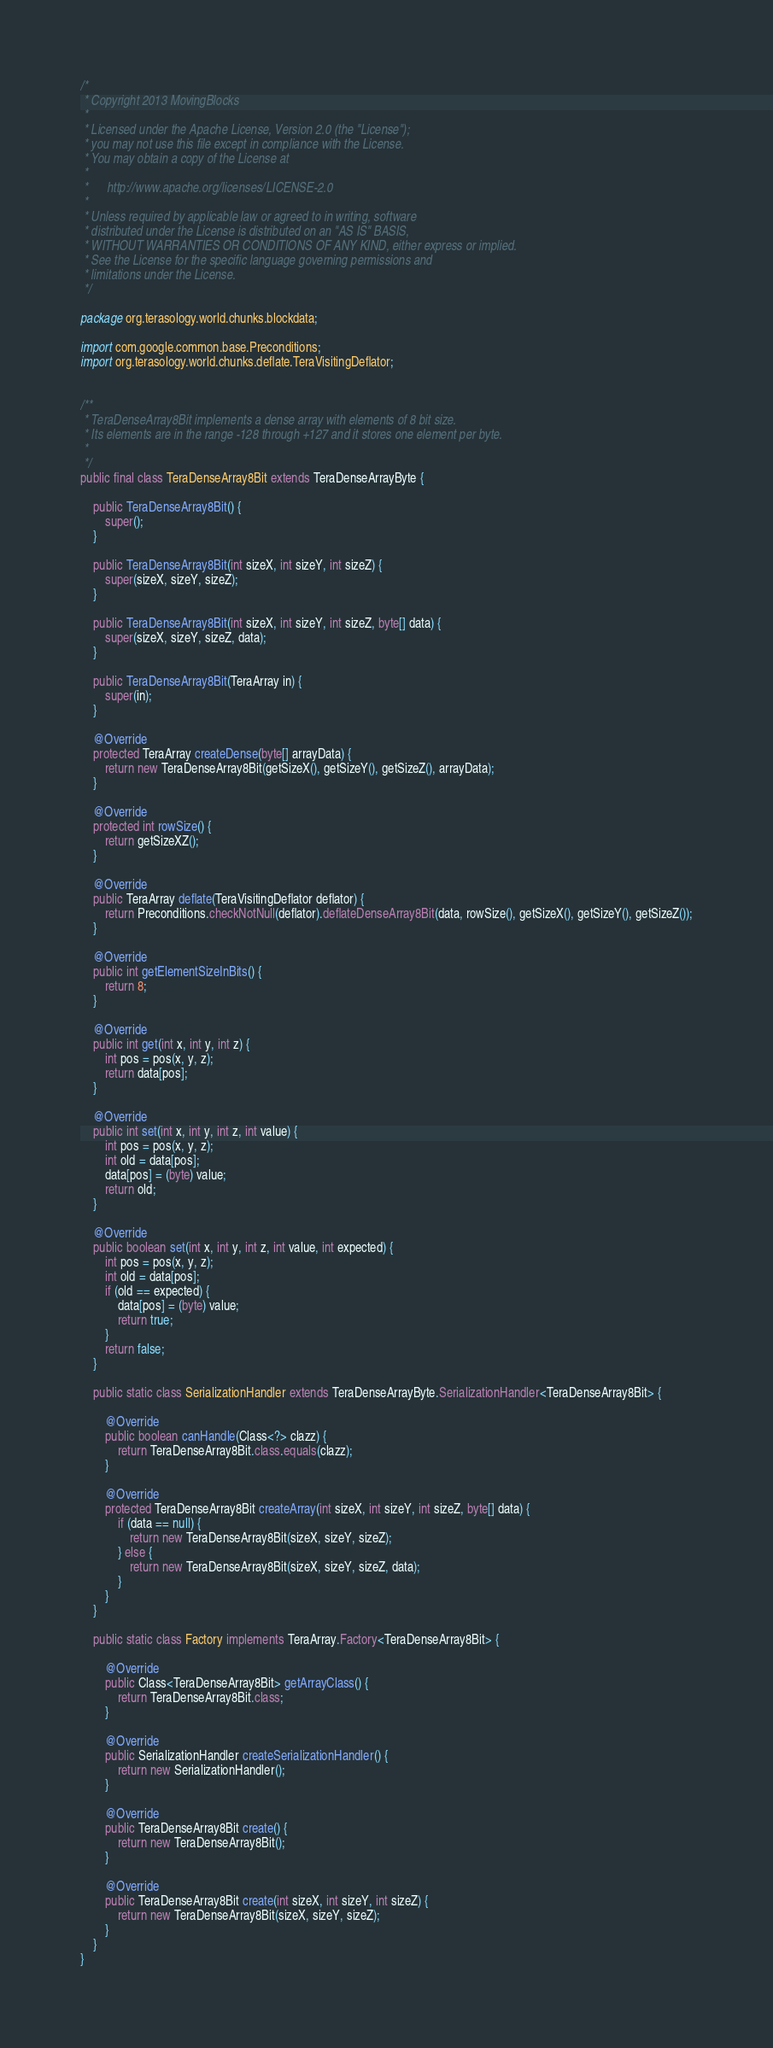<code> <loc_0><loc_0><loc_500><loc_500><_Java_>/*
 * Copyright 2013 MovingBlocks
 *
 * Licensed under the Apache License, Version 2.0 (the "License");
 * you may not use this file except in compliance with the License.
 * You may obtain a copy of the License at
 *
 *      http://www.apache.org/licenses/LICENSE-2.0
 *
 * Unless required by applicable law or agreed to in writing, software
 * distributed under the License is distributed on an "AS IS" BASIS,
 * WITHOUT WARRANTIES OR CONDITIONS OF ANY KIND, either express or implied.
 * See the License for the specific language governing permissions and
 * limitations under the License.
 */

package org.terasology.world.chunks.blockdata;

import com.google.common.base.Preconditions;
import org.terasology.world.chunks.deflate.TeraVisitingDeflator;


/**
 * TeraDenseArray8Bit implements a dense array with elements of 8 bit size.
 * Its elements are in the range -128 through +127 and it stores one element per byte.
 *
 */
public final class TeraDenseArray8Bit extends TeraDenseArrayByte {

    public TeraDenseArray8Bit() {
        super();
    }

    public TeraDenseArray8Bit(int sizeX, int sizeY, int sizeZ) {
        super(sizeX, sizeY, sizeZ);
    }

    public TeraDenseArray8Bit(int sizeX, int sizeY, int sizeZ, byte[] data) {
        super(sizeX, sizeY, sizeZ, data);
    }

    public TeraDenseArray8Bit(TeraArray in) {
        super(in);
    }

    @Override
    protected TeraArray createDense(byte[] arrayData) {
        return new TeraDenseArray8Bit(getSizeX(), getSizeY(), getSizeZ(), arrayData);
    }

    @Override
    protected int rowSize() {
        return getSizeXZ();
    }

    @Override
    public TeraArray deflate(TeraVisitingDeflator deflator) {
        return Preconditions.checkNotNull(deflator).deflateDenseArray8Bit(data, rowSize(), getSizeX(), getSizeY(), getSizeZ());
    }

    @Override
    public int getElementSizeInBits() {
        return 8;
    }

    @Override
    public int get(int x, int y, int z) {
        int pos = pos(x, y, z);
        return data[pos];
    }

    @Override
    public int set(int x, int y, int z, int value) {
        int pos = pos(x, y, z);
        int old = data[pos];
        data[pos] = (byte) value;
        return old;
    }

    @Override
    public boolean set(int x, int y, int z, int value, int expected) {
        int pos = pos(x, y, z);
        int old = data[pos];
        if (old == expected) {
            data[pos] = (byte) value;
            return true;
        }
        return false;
    }

    public static class SerializationHandler extends TeraDenseArrayByte.SerializationHandler<TeraDenseArray8Bit> {

        @Override
        public boolean canHandle(Class<?> clazz) {
            return TeraDenseArray8Bit.class.equals(clazz);
        }

        @Override
        protected TeraDenseArray8Bit createArray(int sizeX, int sizeY, int sizeZ, byte[] data) {
            if (data == null) {
                return new TeraDenseArray8Bit(sizeX, sizeY, sizeZ);
            } else {
                return new TeraDenseArray8Bit(sizeX, sizeY, sizeZ, data);
            }
        }
    }

    public static class Factory implements TeraArray.Factory<TeraDenseArray8Bit> {

        @Override
        public Class<TeraDenseArray8Bit> getArrayClass() {
            return TeraDenseArray8Bit.class;
        }

        @Override
        public SerializationHandler createSerializationHandler() {
            return new SerializationHandler();
        }

        @Override
        public TeraDenseArray8Bit create() {
            return new TeraDenseArray8Bit();
        }

        @Override
        public TeraDenseArray8Bit create(int sizeX, int sizeY, int sizeZ) {
            return new TeraDenseArray8Bit(sizeX, sizeY, sizeZ);
        }
    }
}
</code> 